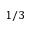<formula> <loc_0><loc_0><loc_500><loc_500>1 / 3</formula> 